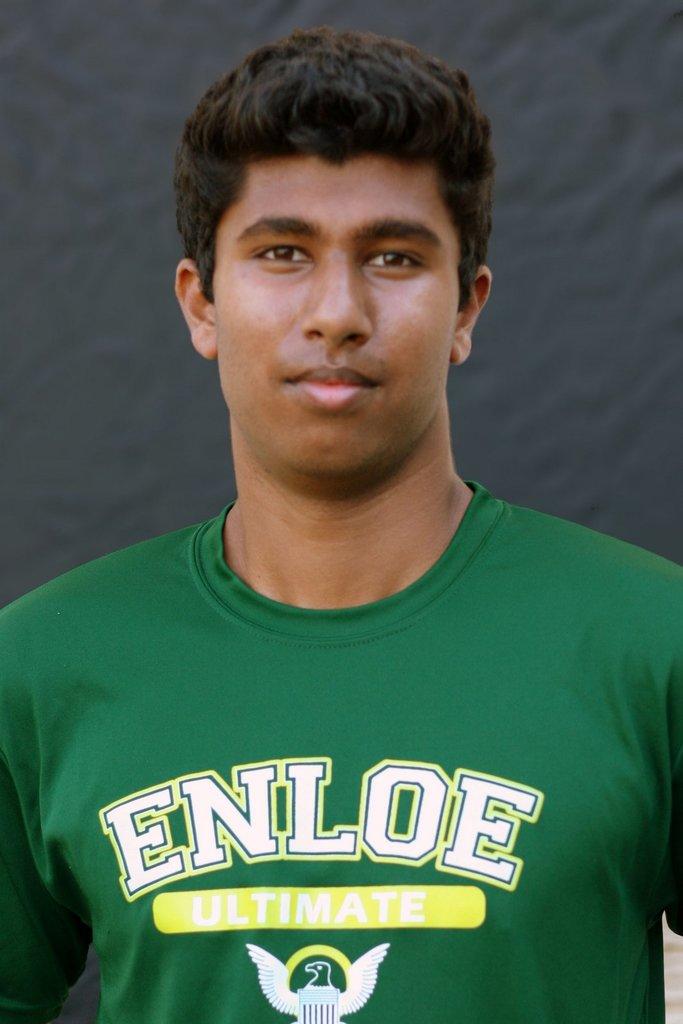What is written in the yellow box?
Keep it short and to the point. Ultimate. 